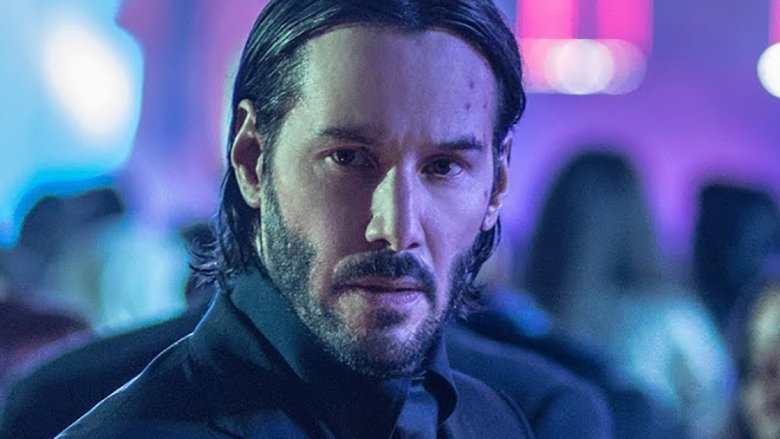Write a detailed description of the given image. The image features a man in a sharp, black suit with long hair and a beard, giving him a rugged yet polished look. He stands in the center of a bustling nightclub, with blurred figures and luminous, colorful lighting in the background. His expression is stern and contemplative, suggesting a moment of tension or deep thought. The contrast between the somber tones of his suit and the vibrant hues of the club's lights creates a dynamic visual. The overall atmosphere conveys a blend of action and drama, characteristic of thrilling cinematic scenes. 